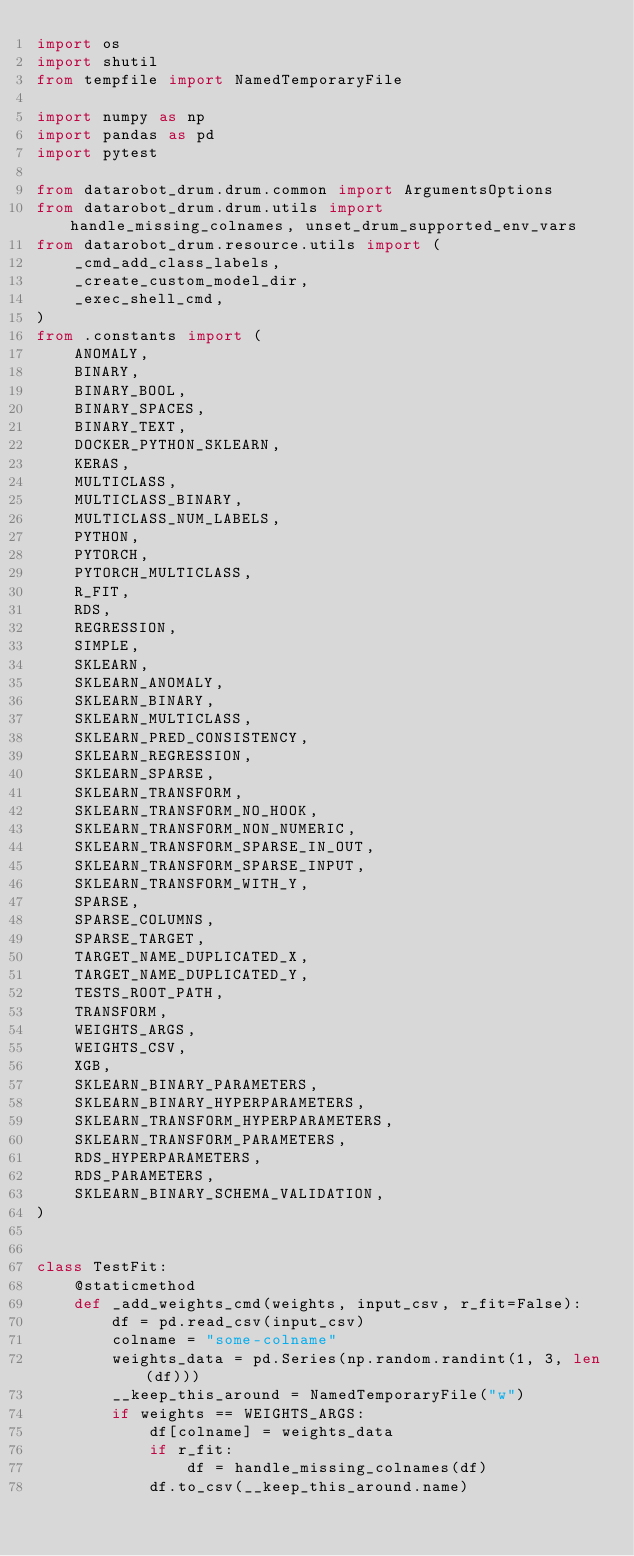<code> <loc_0><loc_0><loc_500><loc_500><_Python_>import os
import shutil
from tempfile import NamedTemporaryFile

import numpy as np
import pandas as pd
import pytest

from datarobot_drum.drum.common import ArgumentsOptions
from datarobot_drum.drum.utils import handle_missing_colnames, unset_drum_supported_env_vars
from datarobot_drum.resource.utils import (
    _cmd_add_class_labels,
    _create_custom_model_dir,
    _exec_shell_cmd,
)
from .constants import (
    ANOMALY,
    BINARY,
    BINARY_BOOL,
    BINARY_SPACES,
    BINARY_TEXT,
    DOCKER_PYTHON_SKLEARN,
    KERAS,
    MULTICLASS,
    MULTICLASS_BINARY,
    MULTICLASS_NUM_LABELS,
    PYTHON,
    PYTORCH,
    PYTORCH_MULTICLASS,
    R_FIT,
    RDS,
    REGRESSION,
    SIMPLE,
    SKLEARN,
    SKLEARN_ANOMALY,
    SKLEARN_BINARY,
    SKLEARN_MULTICLASS,
    SKLEARN_PRED_CONSISTENCY,
    SKLEARN_REGRESSION,
    SKLEARN_SPARSE,
    SKLEARN_TRANSFORM,
    SKLEARN_TRANSFORM_NO_HOOK,
    SKLEARN_TRANSFORM_NON_NUMERIC,
    SKLEARN_TRANSFORM_SPARSE_IN_OUT,
    SKLEARN_TRANSFORM_SPARSE_INPUT,
    SKLEARN_TRANSFORM_WITH_Y,
    SPARSE,
    SPARSE_COLUMNS,
    SPARSE_TARGET,
    TARGET_NAME_DUPLICATED_X,
    TARGET_NAME_DUPLICATED_Y,
    TESTS_ROOT_PATH,
    TRANSFORM,
    WEIGHTS_ARGS,
    WEIGHTS_CSV,
    XGB,
    SKLEARN_BINARY_PARAMETERS,
    SKLEARN_BINARY_HYPERPARAMETERS,
    SKLEARN_TRANSFORM_HYPERPARAMETERS,
    SKLEARN_TRANSFORM_PARAMETERS,
    RDS_HYPERPARAMETERS,
    RDS_PARAMETERS,
    SKLEARN_BINARY_SCHEMA_VALIDATION,
)


class TestFit:
    @staticmethod
    def _add_weights_cmd(weights, input_csv, r_fit=False):
        df = pd.read_csv(input_csv)
        colname = "some-colname"
        weights_data = pd.Series(np.random.randint(1, 3, len(df)))
        __keep_this_around = NamedTemporaryFile("w")
        if weights == WEIGHTS_ARGS:
            df[colname] = weights_data
            if r_fit:
                df = handle_missing_colnames(df)
            df.to_csv(__keep_this_around.name)</code> 